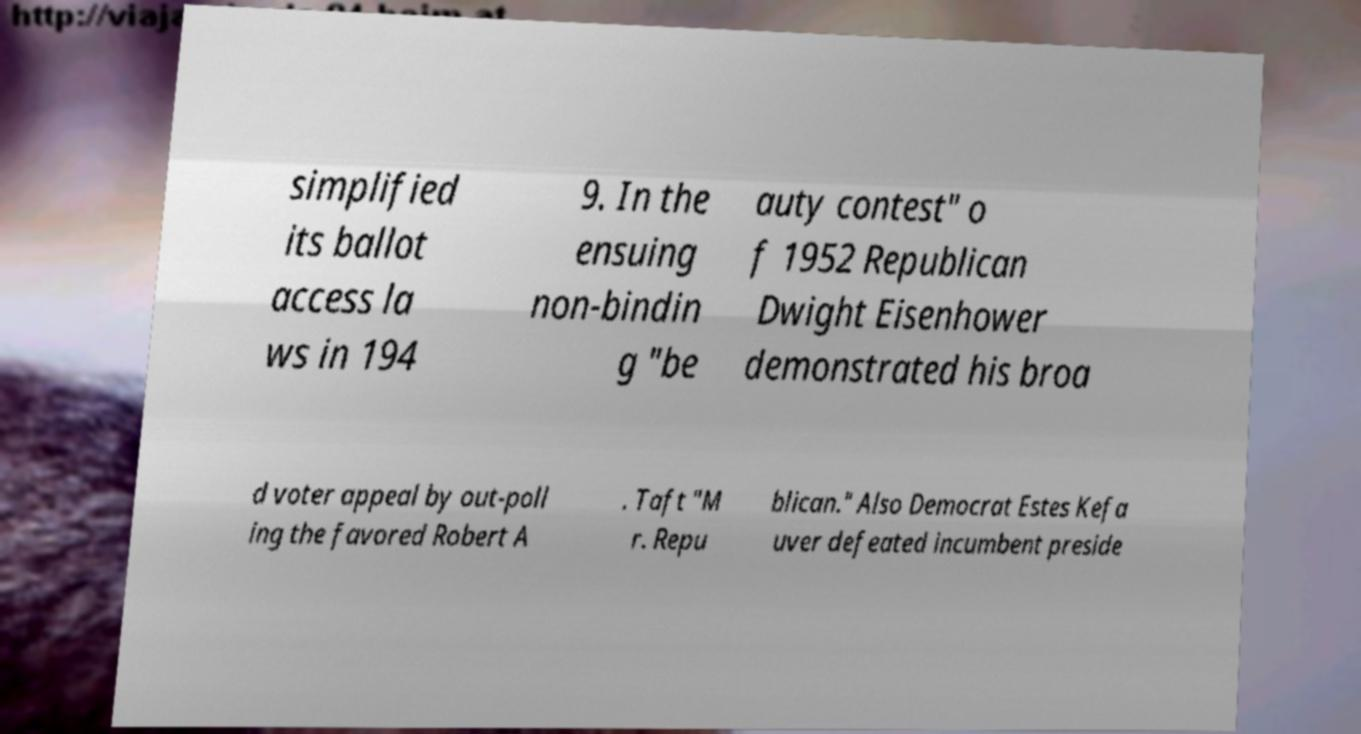Could you extract and type out the text from this image? simplified its ballot access la ws in 194 9. In the ensuing non-bindin g "be auty contest" o f 1952 Republican Dwight Eisenhower demonstrated his broa d voter appeal by out-poll ing the favored Robert A . Taft "M r. Repu blican." Also Democrat Estes Kefa uver defeated incumbent preside 